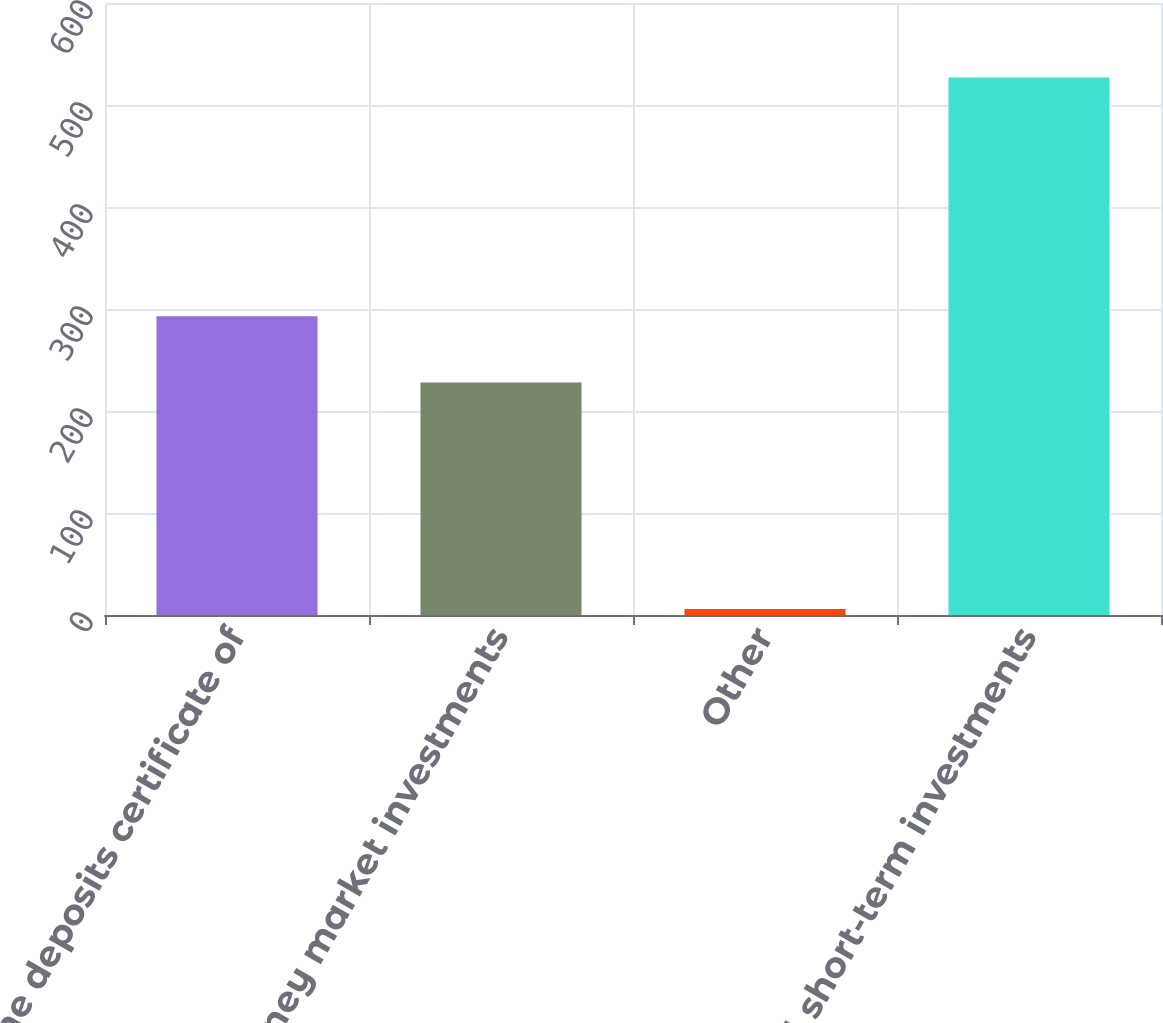Convert chart. <chart><loc_0><loc_0><loc_500><loc_500><bar_chart><fcel>Time deposits certificate of<fcel>Money market investments<fcel>Other<fcel>Total short-term investments<nl><fcel>293<fcel>228<fcel>6<fcel>527<nl></chart> 